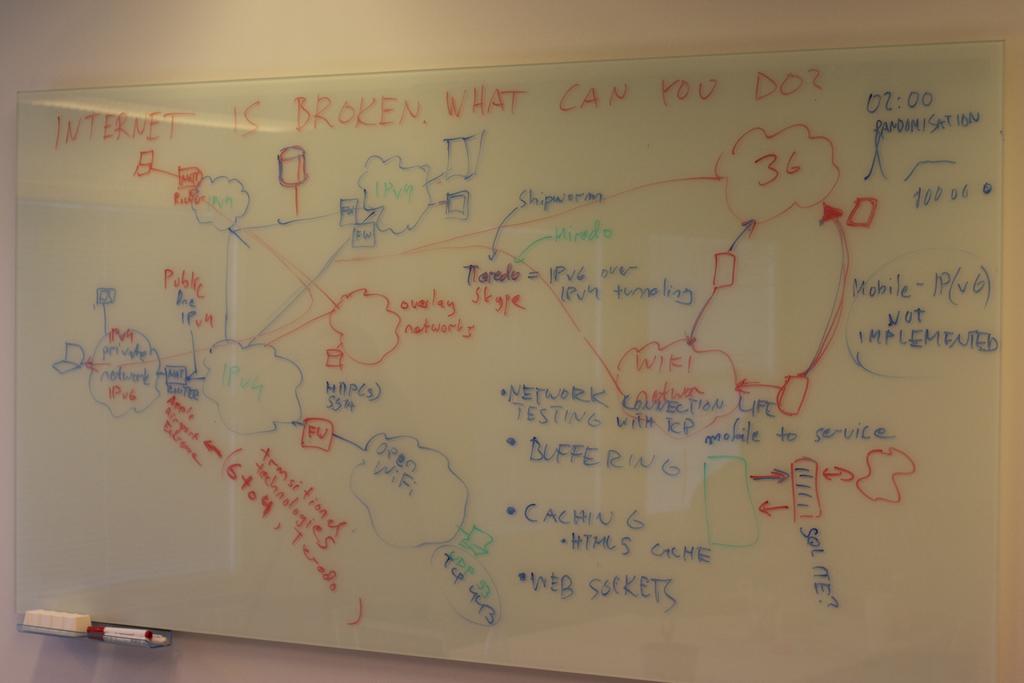What type of sockets is written in blue on the bottom center?
Your response must be concise. Web. 